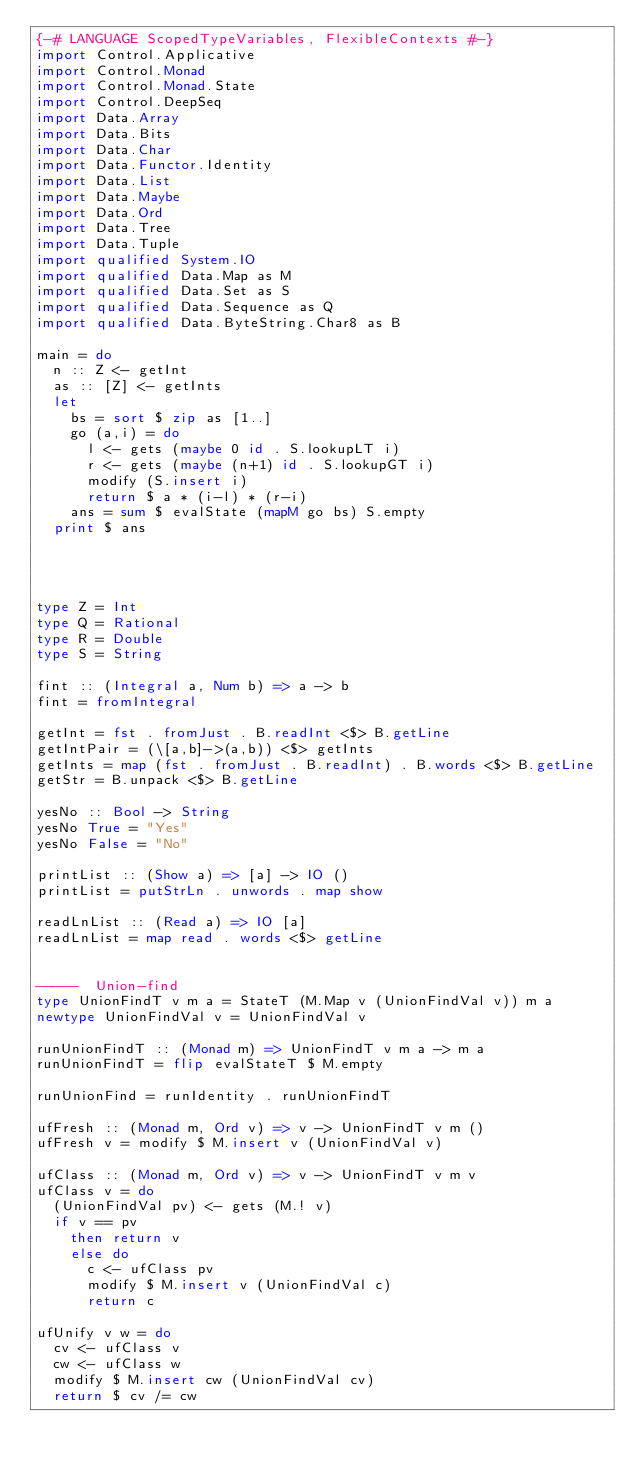Convert code to text. <code><loc_0><loc_0><loc_500><loc_500><_Haskell_>{-# LANGUAGE ScopedTypeVariables, FlexibleContexts #-}
import Control.Applicative
import Control.Monad
import Control.Monad.State
import Control.DeepSeq
import Data.Array
import Data.Bits
import Data.Char
import Data.Functor.Identity
import Data.List
import Data.Maybe
import Data.Ord
import Data.Tree
import Data.Tuple
import qualified System.IO
import qualified Data.Map as M
import qualified Data.Set as S
import qualified Data.Sequence as Q
import qualified Data.ByteString.Char8 as B

main = do
  n :: Z <- getInt
  as :: [Z] <- getInts
  let
    bs = sort $ zip as [1..]
    go (a,i) = do
      l <- gets (maybe 0 id . S.lookupLT i)
      r <- gets (maybe (n+1) id . S.lookupGT i)
      modify (S.insert i)
      return $ a * (i-l) * (r-i)
    ans = sum $ evalState (mapM go bs) S.empty
  print $ ans



 
type Z = Int
type Q = Rational
type R = Double
type S = String

fint :: (Integral a, Num b) => a -> b
fint = fromIntegral

getInt = fst . fromJust . B.readInt <$> B.getLine
getIntPair = (\[a,b]->(a,b)) <$> getInts
getInts = map (fst . fromJust . B.readInt) . B.words <$> B.getLine
getStr = B.unpack <$> B.getLine

yesNo :: Bool -> String
yesNo True = "Yes"
yesNo False = "No"

printList :: (Show a) => [a] -> IO ()
printList = putStrLn . unwords . map show

readLnList :: (Read a) => IO [a]
readLnList = map read . words <$> getLine


-----  Union-find
type UnionFindT v m a = StateT (M.Map v (UnionFindVal v)) m a
newtype UnionFindVal v = UnionFindVal v

runUnionFindT :: (Monad m) => UnionFindT v m a -> m a
runUnionFindT = flip evalStateT $ M.empty

runUnionFind = runIdentity . runUnionFindT

ufFresh :: (Monad m, Ord v) => v -> UnionFindT v m ()
ufFresh v = modify $ M.insert v (UnionFindVal v)

ufClass :: (Monad m, Ord v) => v -> UnionFindT v m v
ufClass v = do
  (UnionFindVal pv) <- gets (M.! v)
  if v == pv
    then return v
    else do
      c <- ufClass pv
      modify $ M.insert v (UnionFindVal c)
      return c

ufUnify v w = do
  cv <- ufClass v
  cw <- ufClass w
  modify $ M.insert cw (UnionFindVal cv)
  return $ cv /= cw
</code> 